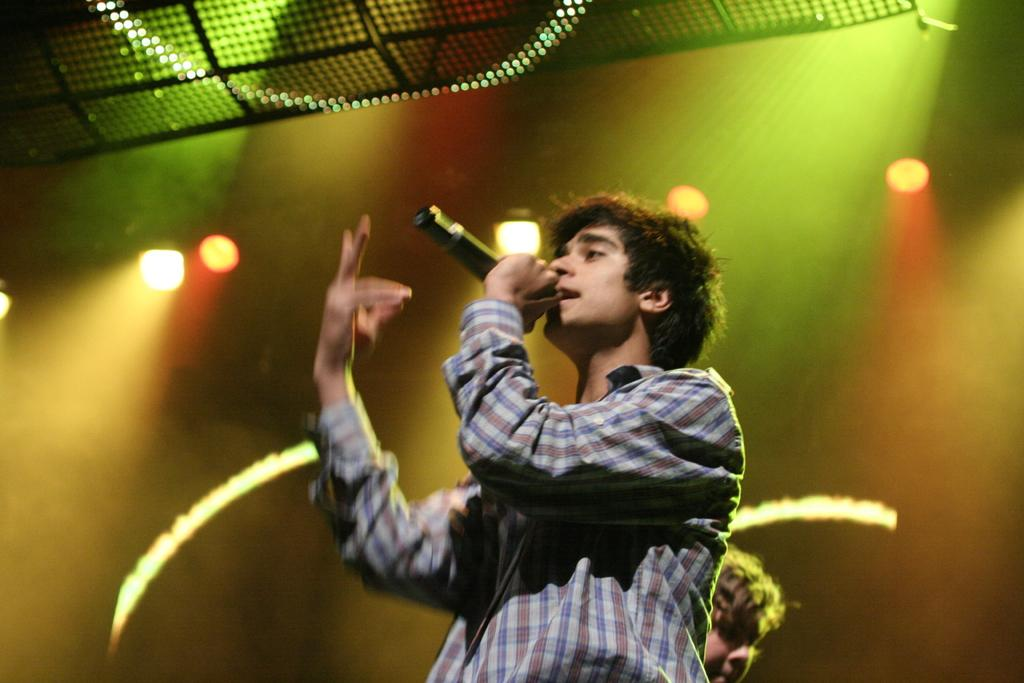What can be seen in the background of the image? There is a wall in the image. What is present in the image that provides illumination? There are lights in the image. Can you describe the person in the image? The person is wearing a grey color dress and is holding a mic. What type of cushion is the person sitting on during their journey in the image? There is no journey or cushion present in the image; it features a person holding a mic in front of a wall with lights. Can you tell me how many airplanes are visible in the image? There are no airplanes present in the image. 